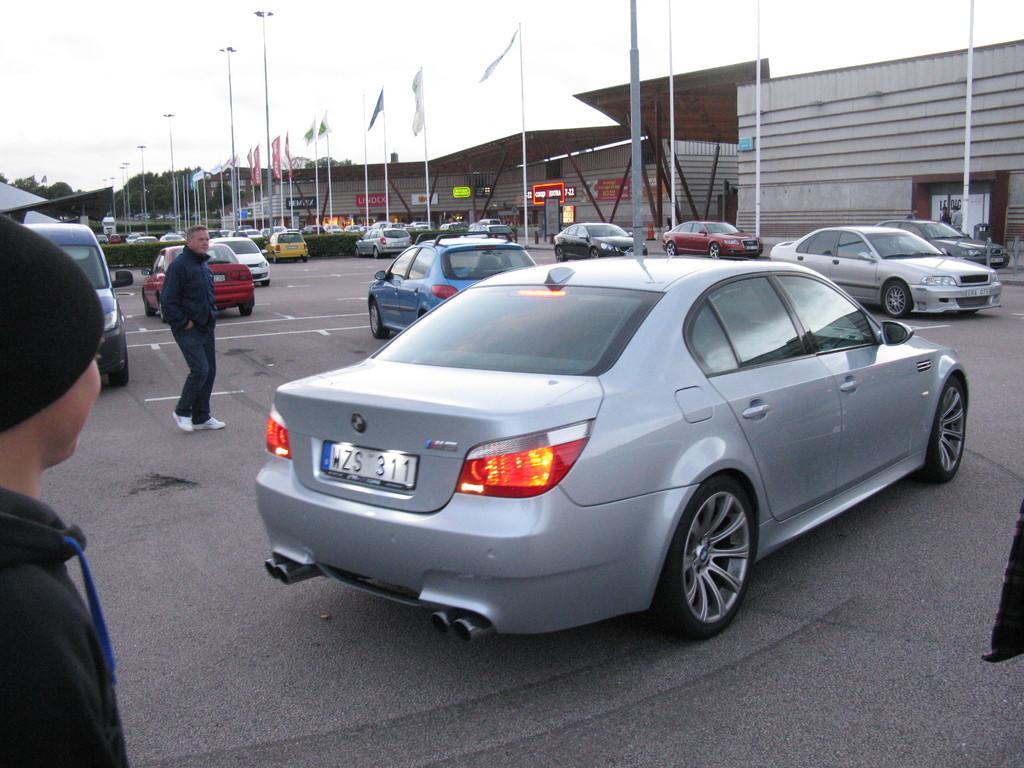What is this car's license plate number?
Keep it short and to the point. Wzs 311. What is the car's model?
Provide a short and direct response. Bmw. 